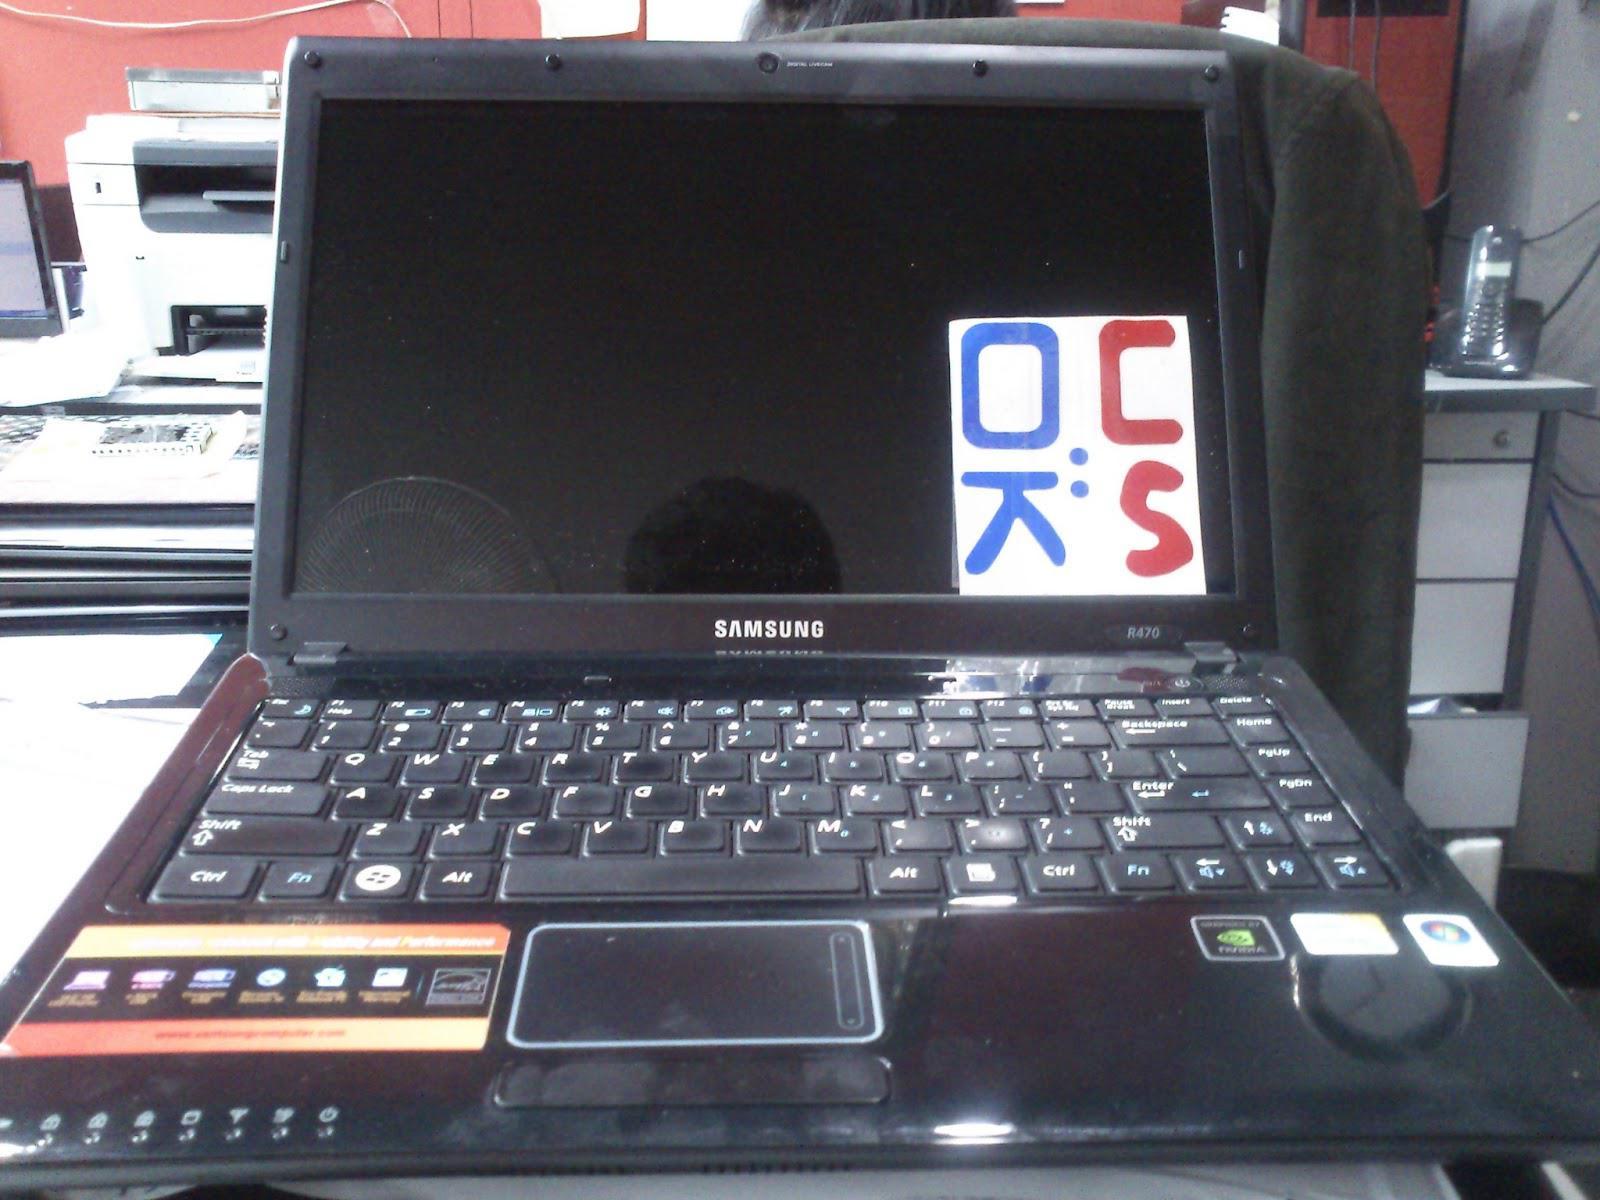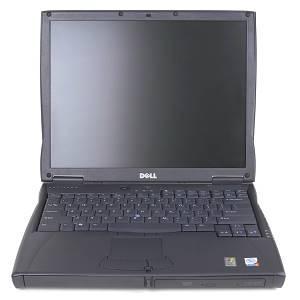The first image is the image on the left, the second image is the image on the right. For the images shown, is this caption "In one image, laptop computers are lined in rows three across, with at least the first row fully open." true? Answer yes or no. No. The first image is the image on the left, the second image is the image on the right. Examine the images to the left and right. Is the description "An image shows rows of lap stocks arranged three across." accurate? Answer yes or no. No. 